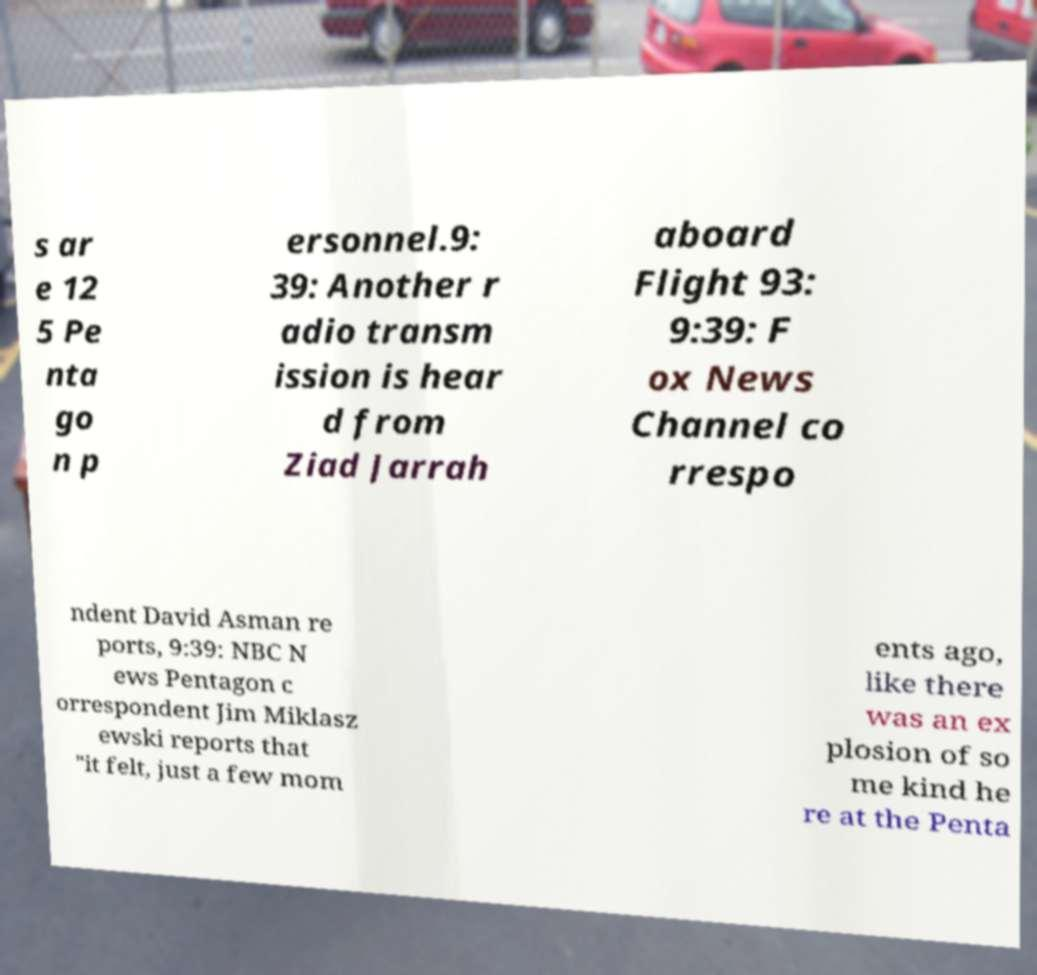Could you extract and type out the text from this image? s ar e 12 5 Pe nta go n p ersonnel.9: 39: Another r adio transm ission is hear d from Ziad Jarrah aboard Flight 93: 9:39: F ox News Channel co rrespo ndent David Asman re ports, 9:39: NBC N ews Pentagon c orrespondent Jim Miklasz ewski reports that "it felt, just a few mom ents ago, like there was an ex plosion of so me kind he re at the Penta 